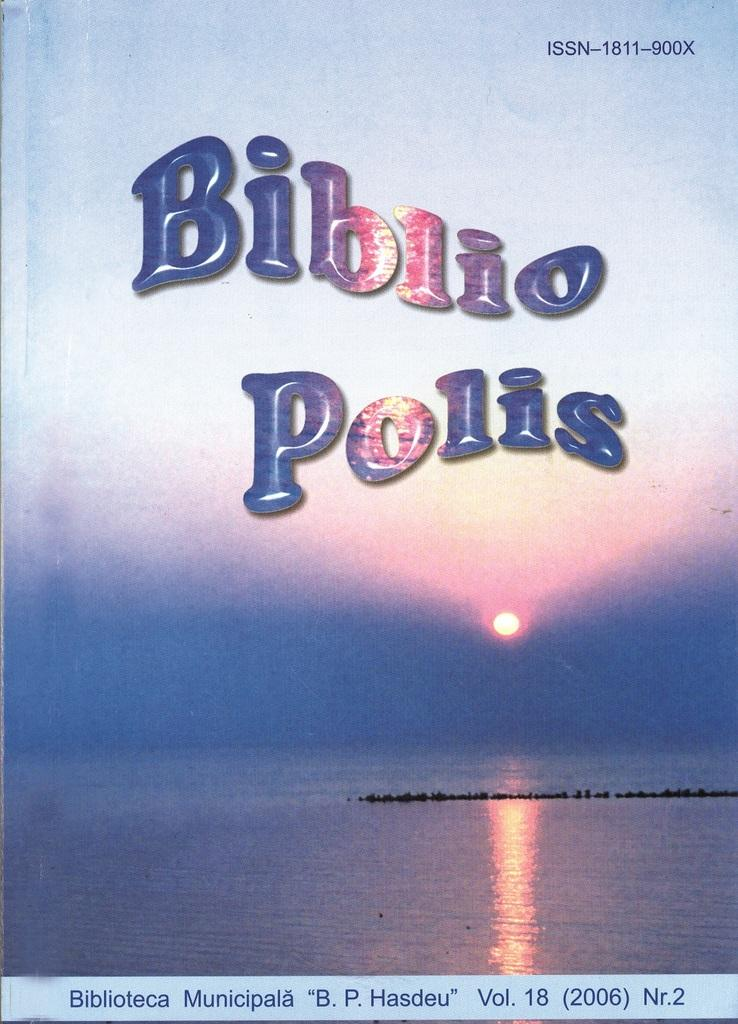Provide a one-sentence caption for the provided image. A Biblio Polio textbook shows a body of water with a sun in the distance. 